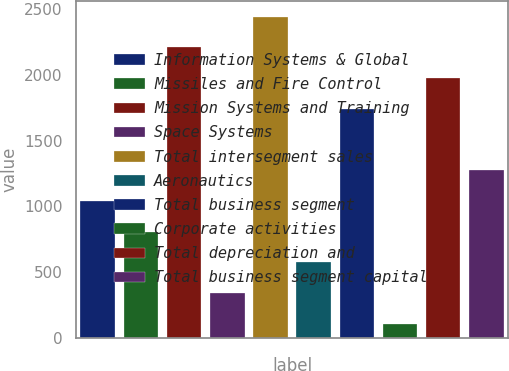Convert chart to OTSL. <chart><loc_0><loc_0><loc_500><loc_500><bar_chart><fcel>Information Systems & Global<fcel>Missiles and Fire Control<fcel>Mission Systems and Training<fcel>Space Systems<fcel>Total intersegment sales<fcel>Aeronautics<fcel>Total business segment<fcel>Corporate activities<fcel>Total depreciation and<fcel>Total business segment capital<nl><fcel>1041.4<fcel>807.8<fcel>2209.4<fcel>340.6<fcel>2443<fcel>574.2<fcel>1742.2<fcel>107<fcel>1975.8<fcel>1275<nl></chart> 